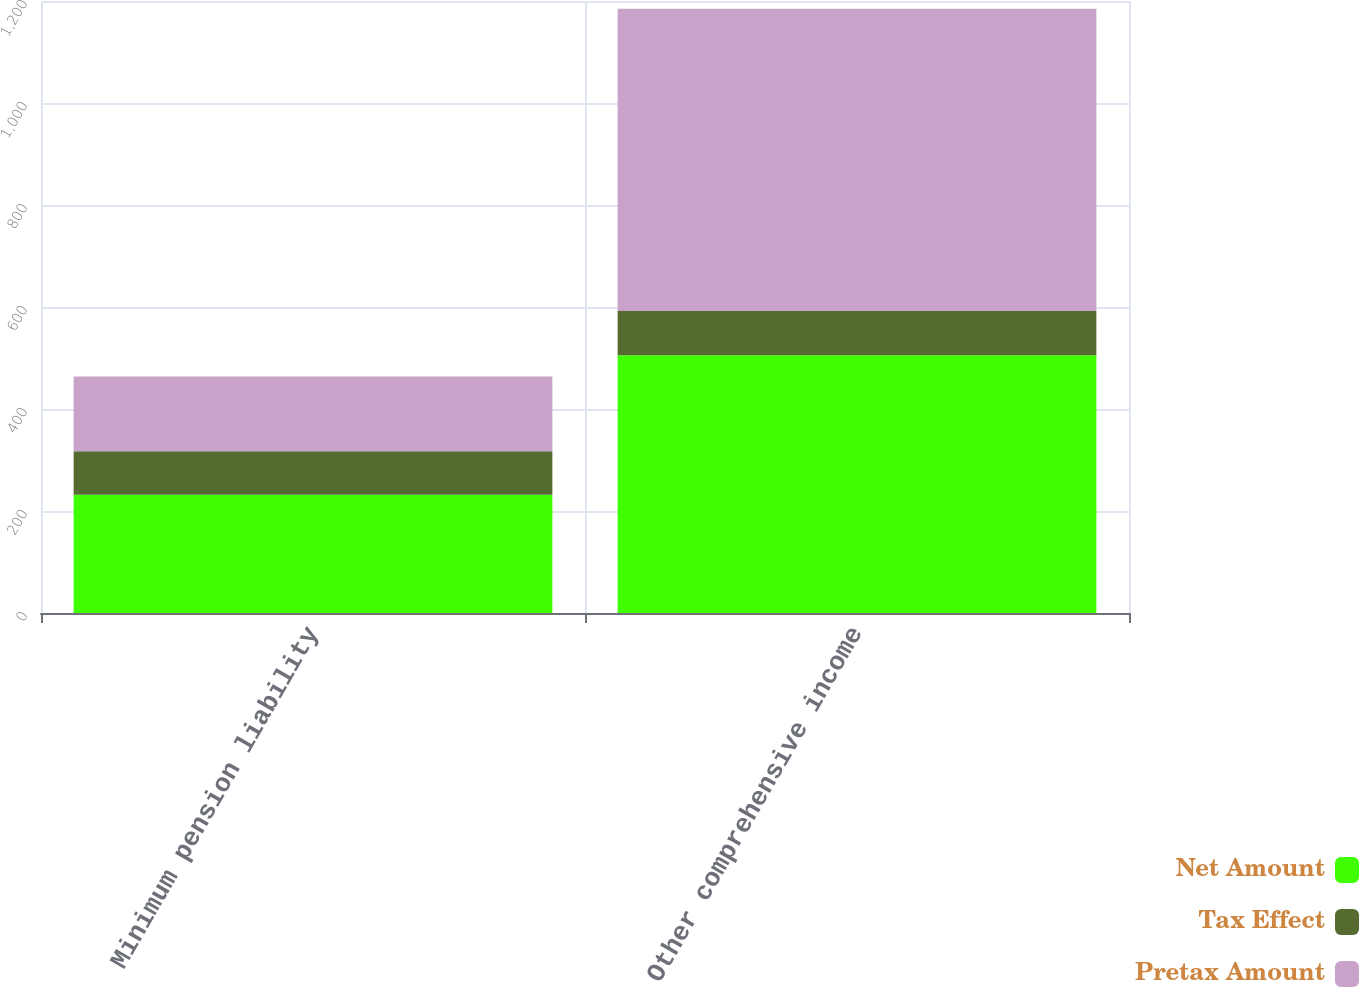Convert chart to OTSL. <chart><loc_0><loc_0><loc_500><loc_500><stacked_bar_chart><ecel><fcel>Minimum pension liability<fcel>Other comprehensive income<nl><fcel>Net Amount<fcel>231.8<fcel>505.4<nl><fcel>Tax Effect<fcel>85.6<fcel>86.9<nl><fcel>Pretax Amount<fcel>146.2<fcel>592.3<nl></chart> 